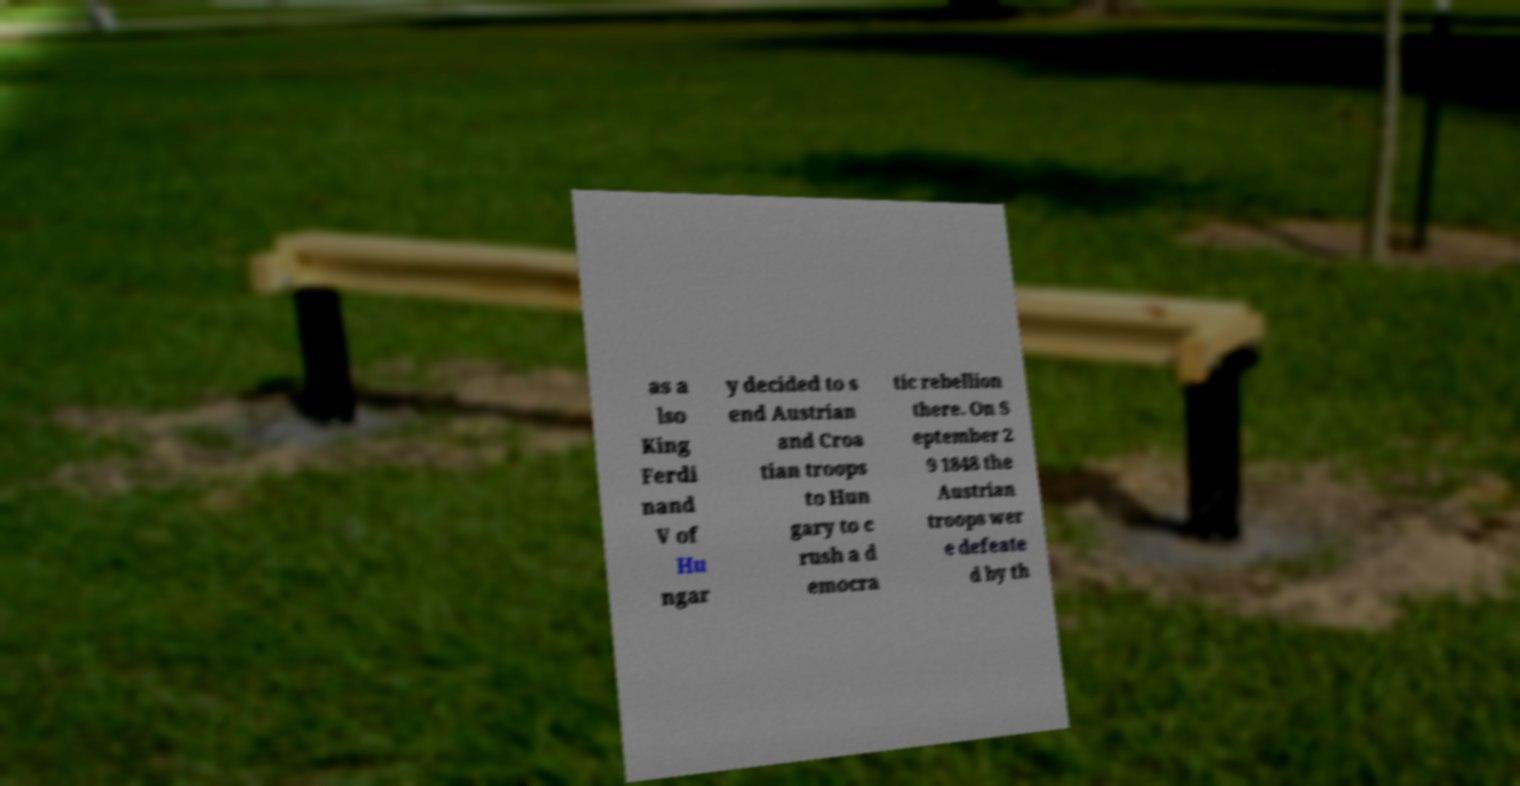I need the written content from this picture converted into text. Can you do that? as a lso King Ferdi nand V of Hu ngar y decided to s end Austrian and Croa tian troops to Hun gary to c rush a d emocra tic rebellion there. On S eptember 2 9 1848 the Austrian troops wer e defeate d by th 